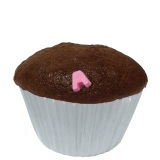Can you come up with a haiku about this cupcake? Chocolate delight,
Pink heart sitting on the top,
Sweet joy with each bite. 